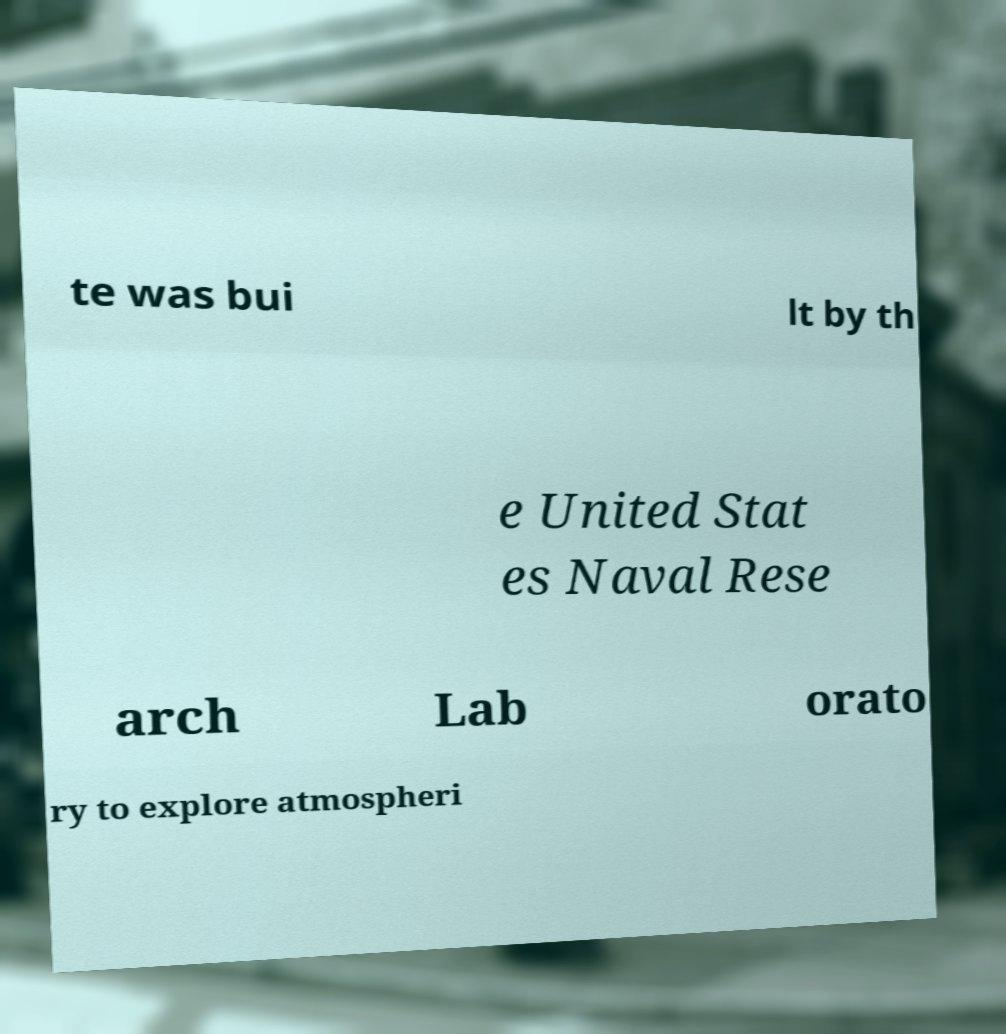Please read and relay the text visible in this image. What does it say? te was bui lt by th e United Stat es Naval Rese arch Lab orato ry to explore atmospheri 